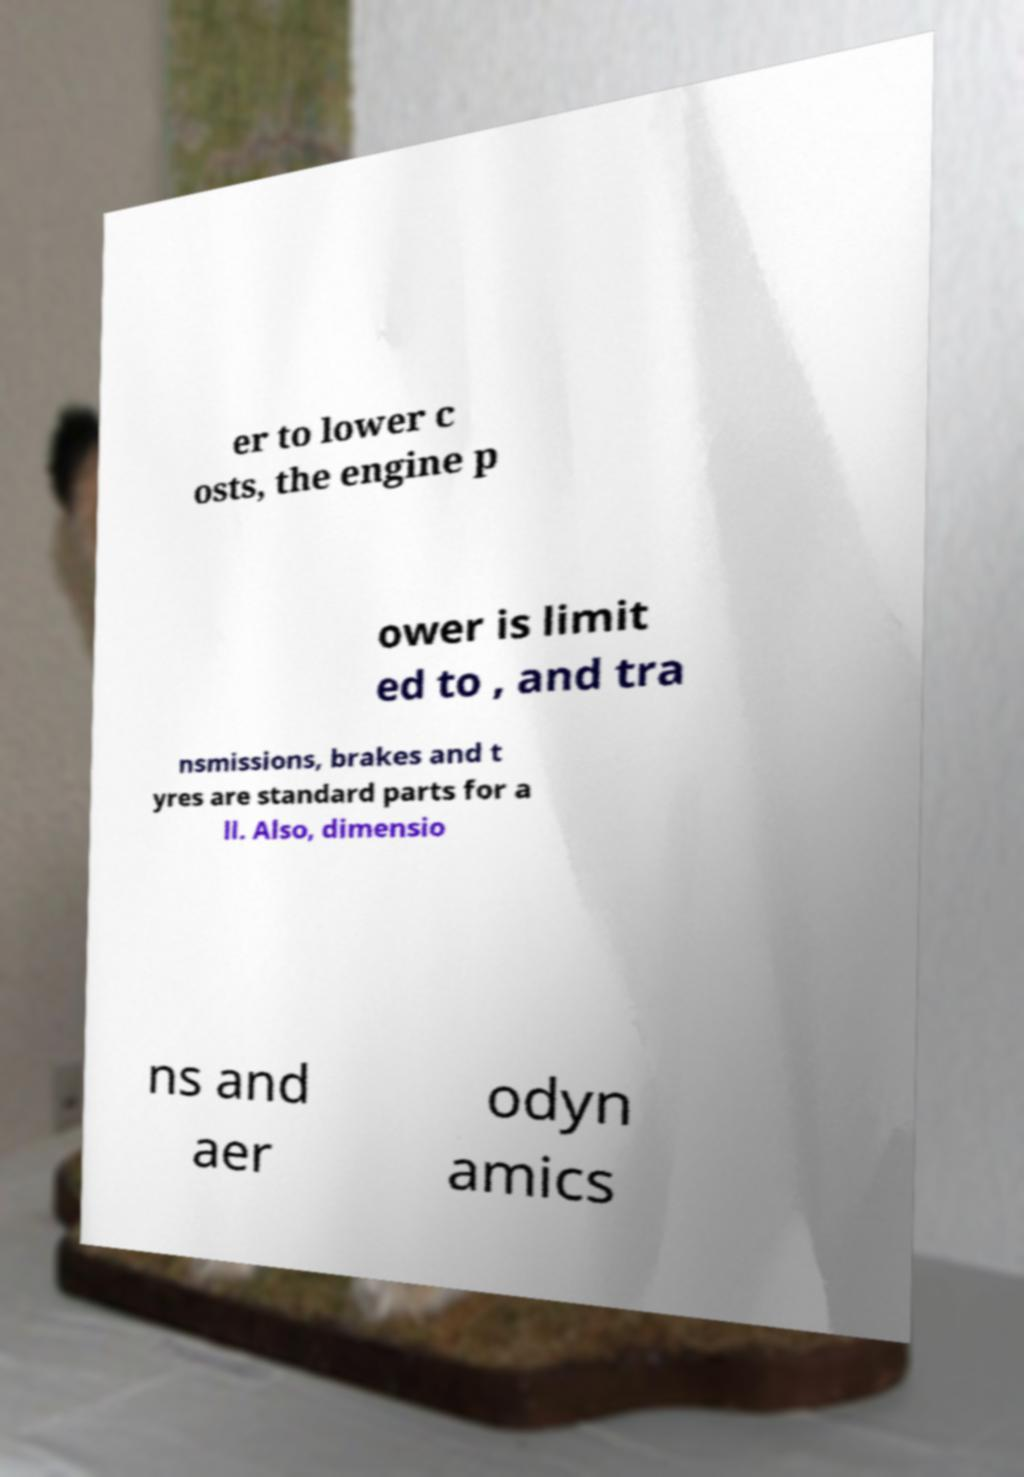Could you extract and type out the text from this image? er to lower c osts, the engine p ower is limit ed to , and tra nsmissions, brakes and t yres are standard parts for a ll. Also, dimensio ns and aer odyn amics 